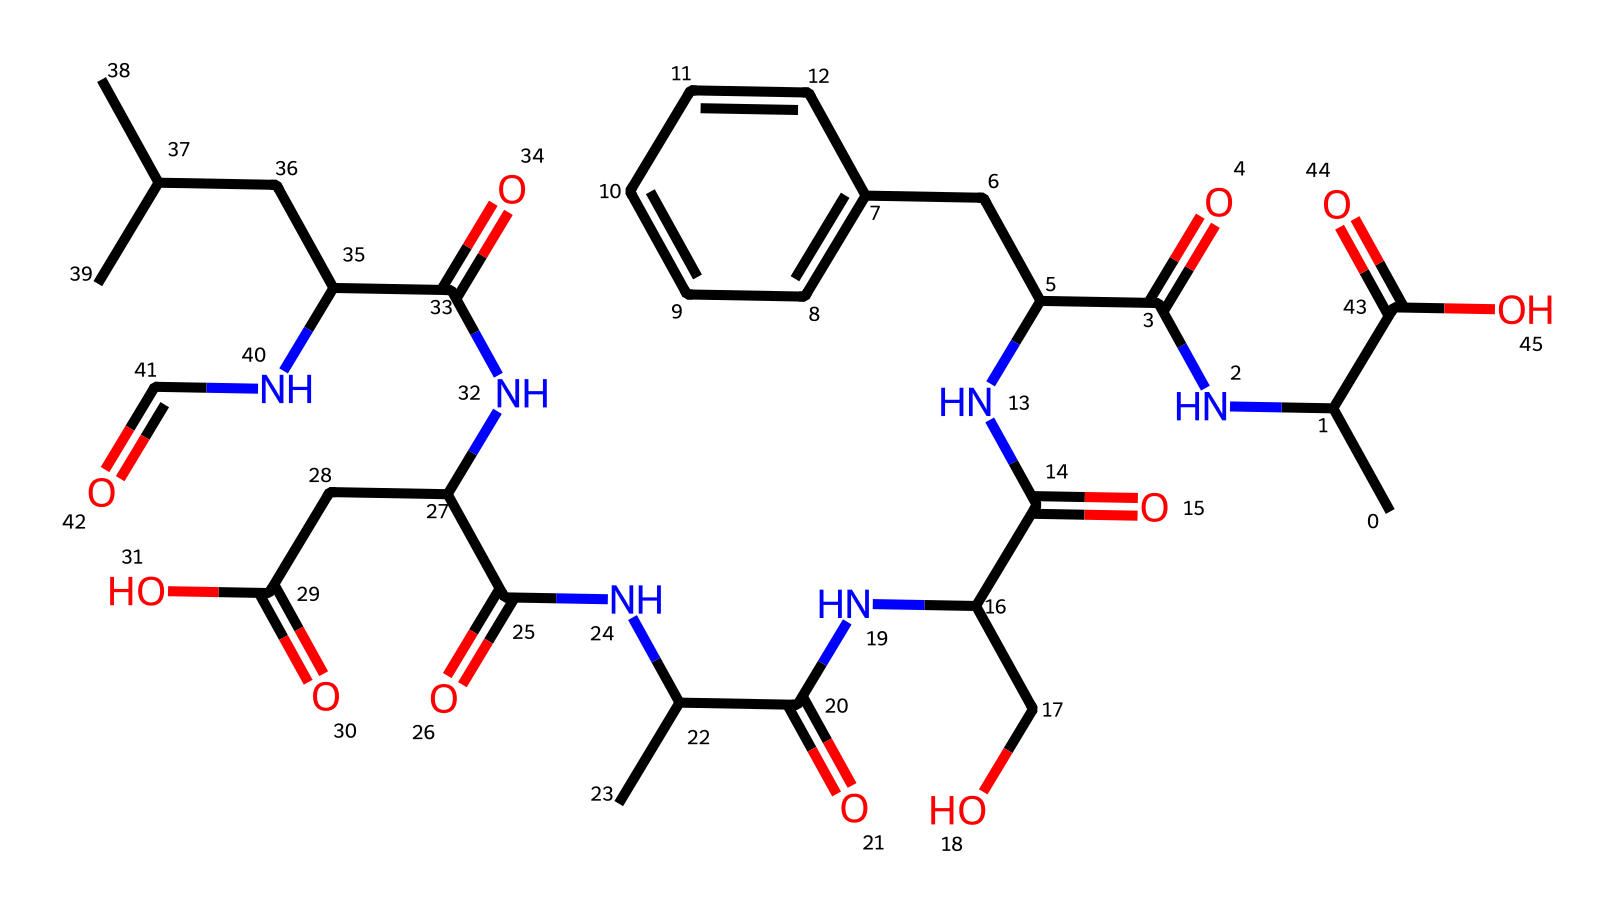What is the primary functional group present in the chemical structure? The chemical structure contains multiple amides as indicated by the nitrogen atoms bonded to carbonyl groups (C=O), each identified by the structure of NC=O.
Answer: amide How many carbon atoms are present in the chemical structure? To determine this, we count all the carbon symbols (C) in the SMILES representation, noting that the structure contains multiple alkyl and aromatic groups. There are 20 carbon atoms.
Answer: 20 What type of fiber is this chemical structure associated with? The structure corresponds to silk fibers, which are protein-based fibers, as indicated by the presence of amino acid-like linkages (e.g., amides).
Answer: protein How many nitrogen atoms are found in the chemical structure? By counting the nitrogen (N) symbols in the chemical's SMILES representation, we find that there are 6 nitrogen atoms contributing to the amide linkages.
Answer: 6 What does the presence of a carboxylic acid group suggest about the fiber's properties? The carboxylic acid group (–COOH) generally suggests that the fiber may have a polar characteristic, allowing for better dye affinity and moisture retention.
Answer: polar characteristic Which part of the chemical structure contributes to silk's luster? The presence of aromatic rings within the structure (noted in the part CC1=CC=CC=C1) contributes to the intrinsic sheen and luster of silk fibers.
Answer: aromatic rings What is the role of methylene (–CH2–) groups in this chemical structure? Methylene groups typically provide flexibility and contribute to the chain length of the fibers, enhancing the tensile strength and resilience of silk.
Answer: flexibility 